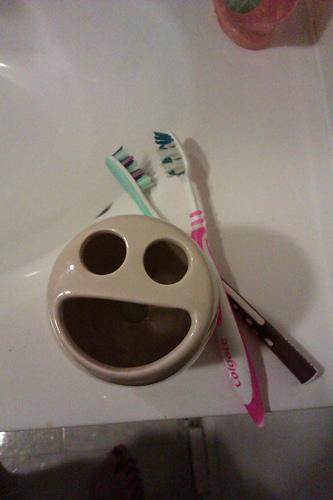How many toothbrushes are there?
Give a very brief answer. 2. 